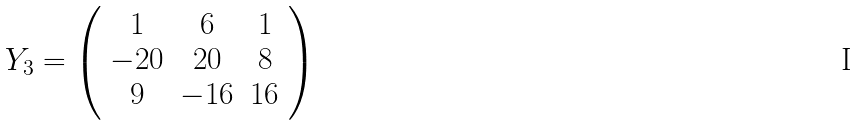Convert formula to latex. <formula><loc_0><loc_0><loc_500><loc_500>Y _ { 3 } = \left ( \begin{array} { c c c } 1 & 6 & 1 \\ - 2 0 & 2 0 & 8 \\ 9 & - 1 6 & 1 6 \end{array} \right )</formula> 